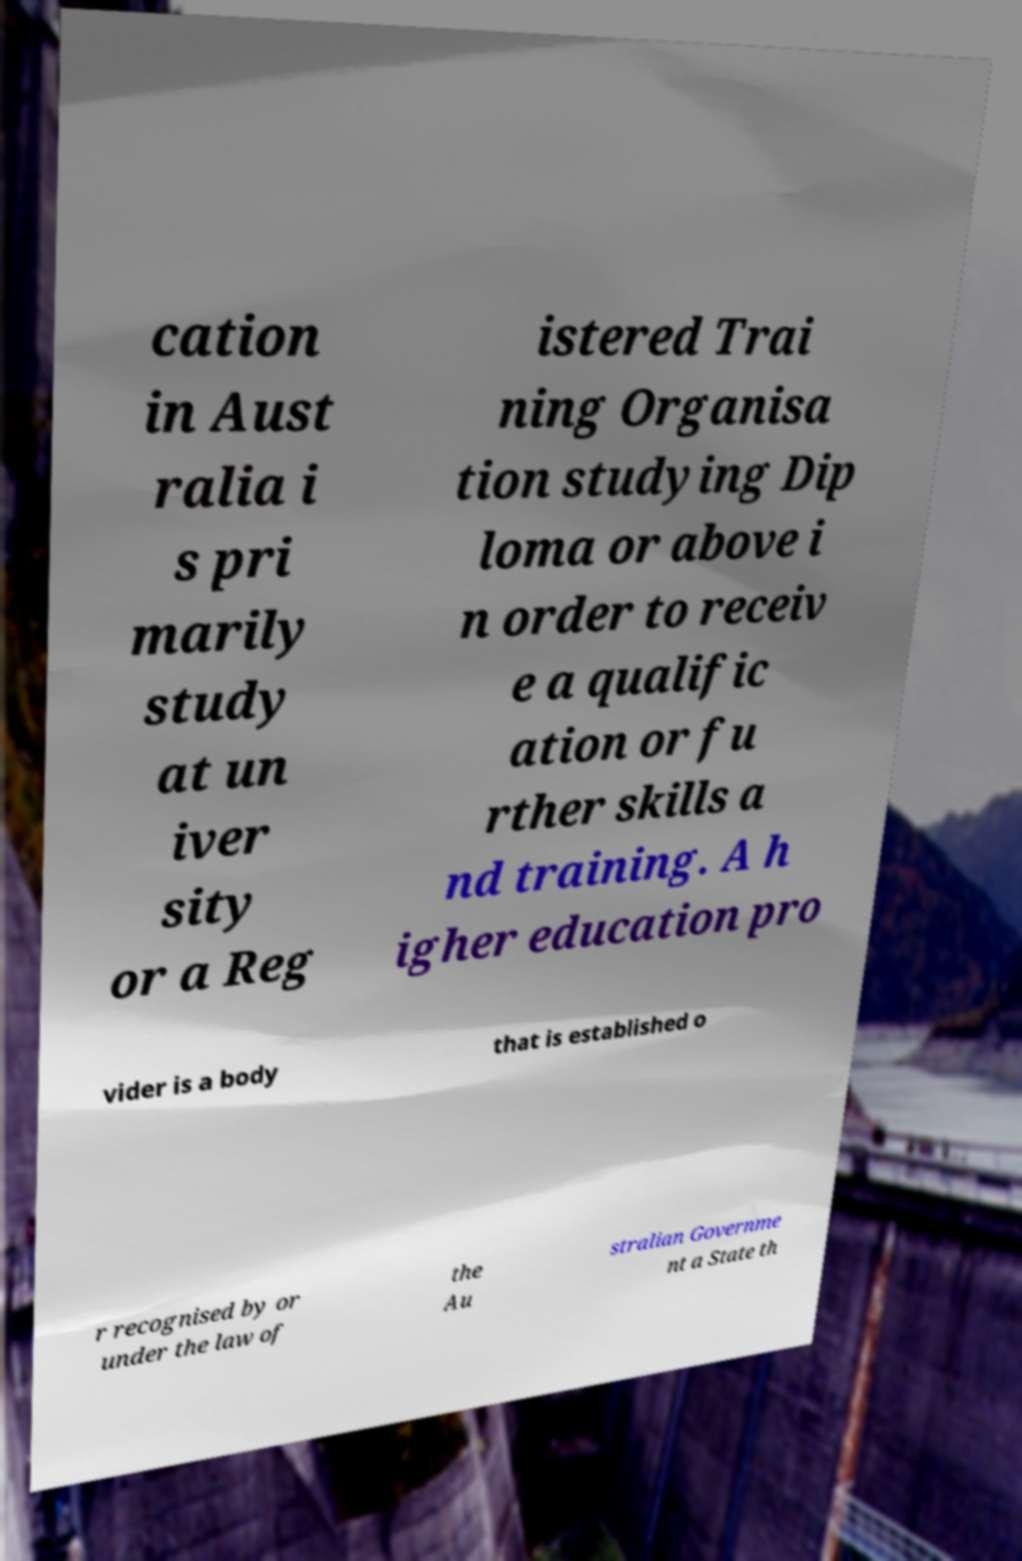Can you accurately transcribe the text from the provided image for me? cation in Aust ralia i s pri marily study at un iver sity or a Reg istered Trai ning Organisa tion studying Dip loma or above i n order to receiv e a qualific ation or fu rther skills a nd training. A h igher education pro vider is a body that is established o r recognised by or under the law of the Au stralian Governme nt a State th 